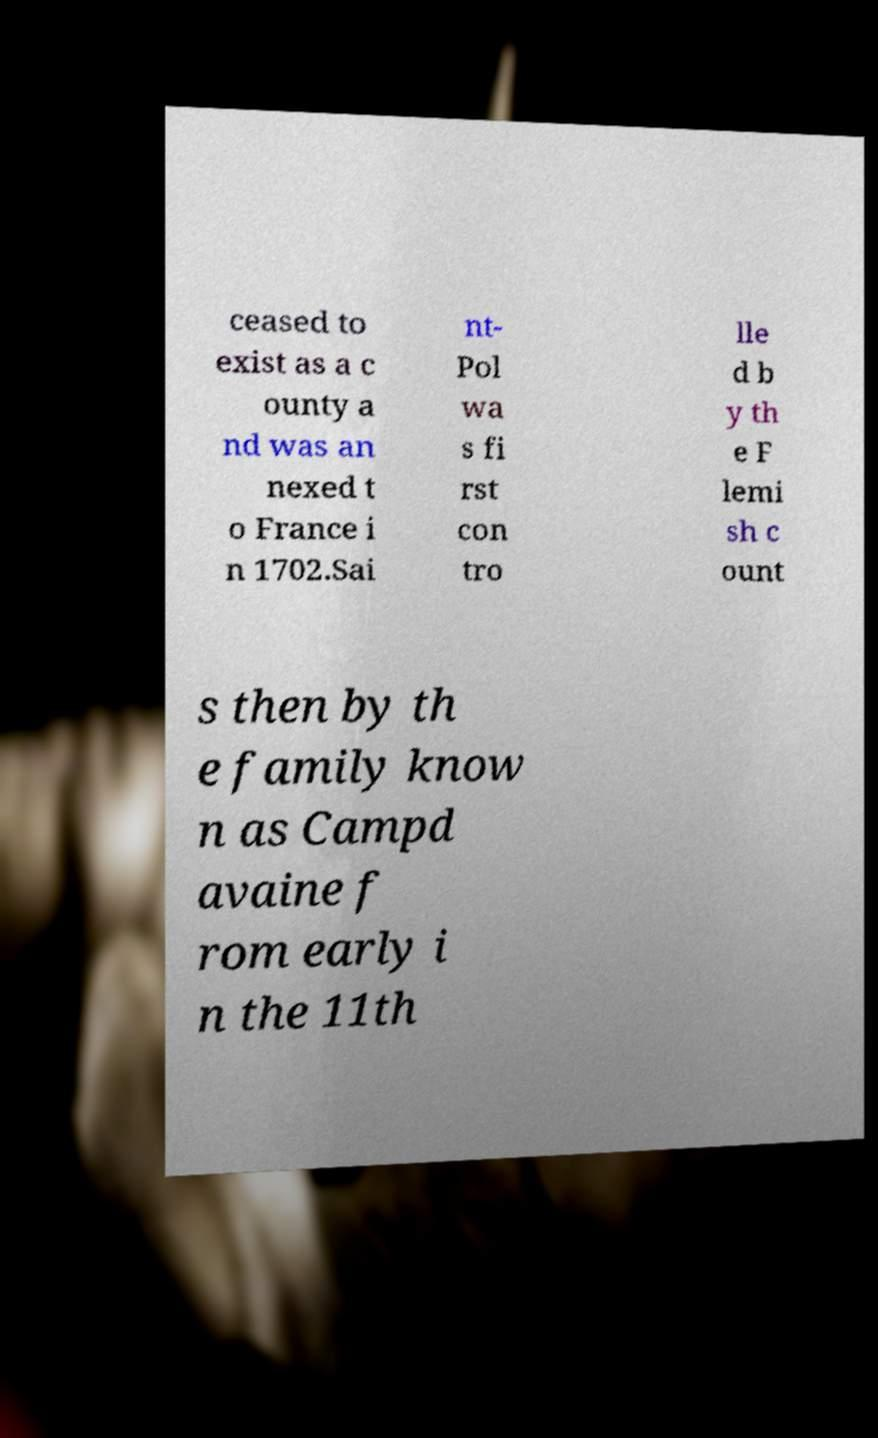There's text embedded in this image that I need extracted. Can you transcribe it verbatim? ceased to exist as a c ounty a nd was an nexed t o France i n 1702.Sai nt- Pol wa s fi rst con tro lle d b y th e F lemi sh c ount s then by th e family know n as Campd avaine f rom early i n the 11th 